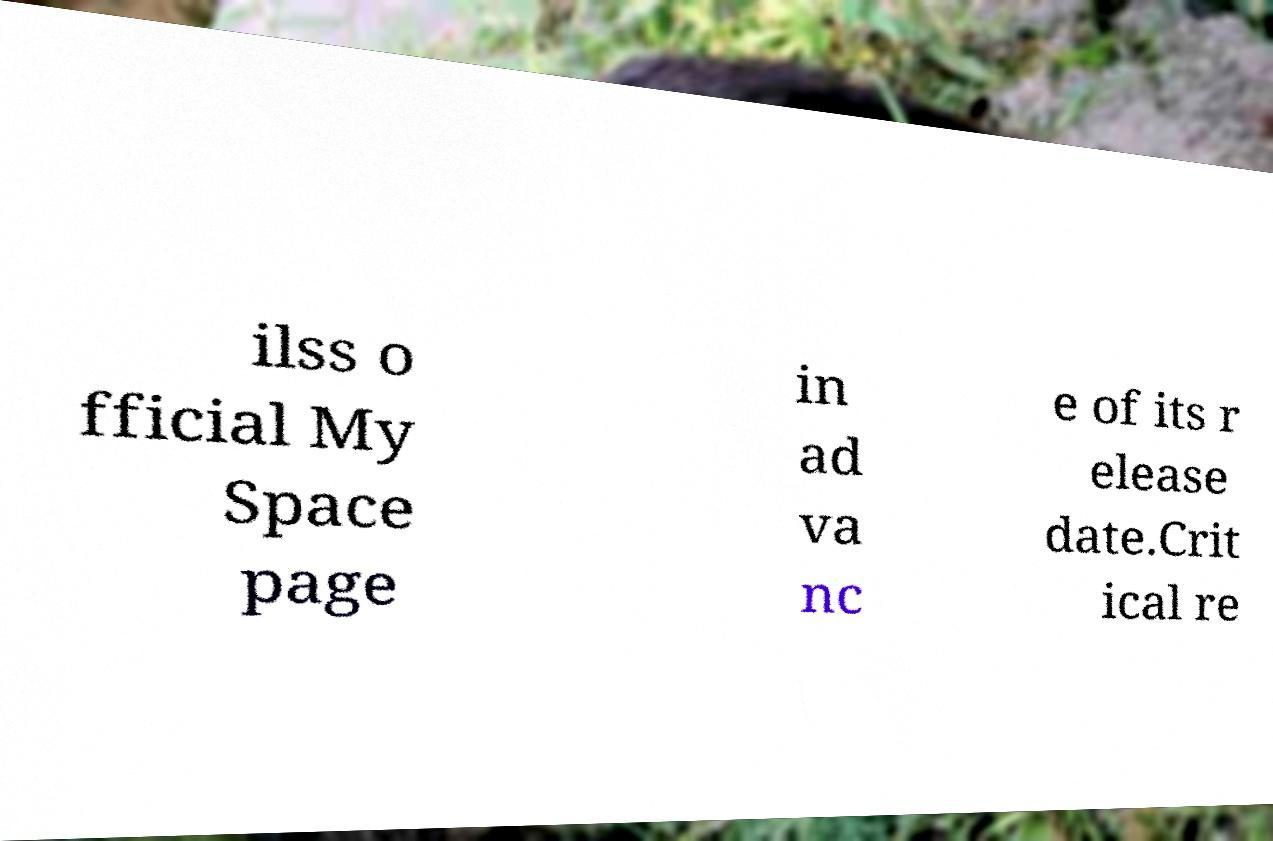What messages or text are displayed in this image? I need them in a readable, typed format. ilss o fficial My Space page in ad va nc e of its r elease date.Crit ical re 